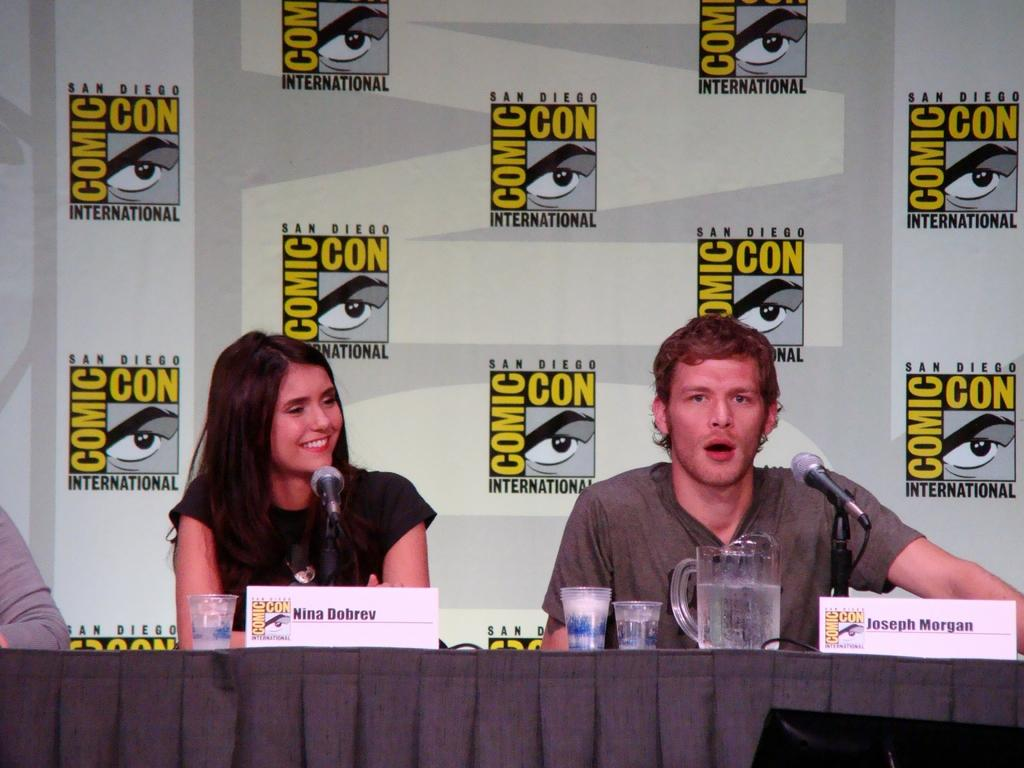How many people are present in the image? There are two people sitting in the image. What objects are visible in the image that might be used for amplifying sound? There are microphones in the image. What items can be seen in the image that might be used for drinking? There are glasses and a mug in the image. What objects are present in the image that might be used for identification? There are name boards in the image. What is on the table in the image? There is a mug on the table in the image. What can be seen on the wall in the background of the image? There are posts on a wall in the background of the image. What type of stocking is hanging on the wall in the image? There is no stocking present in the image. What type of collar is visible on the people in the image? The people in the image are not wearing collars, so it cannot be determined from the image. 